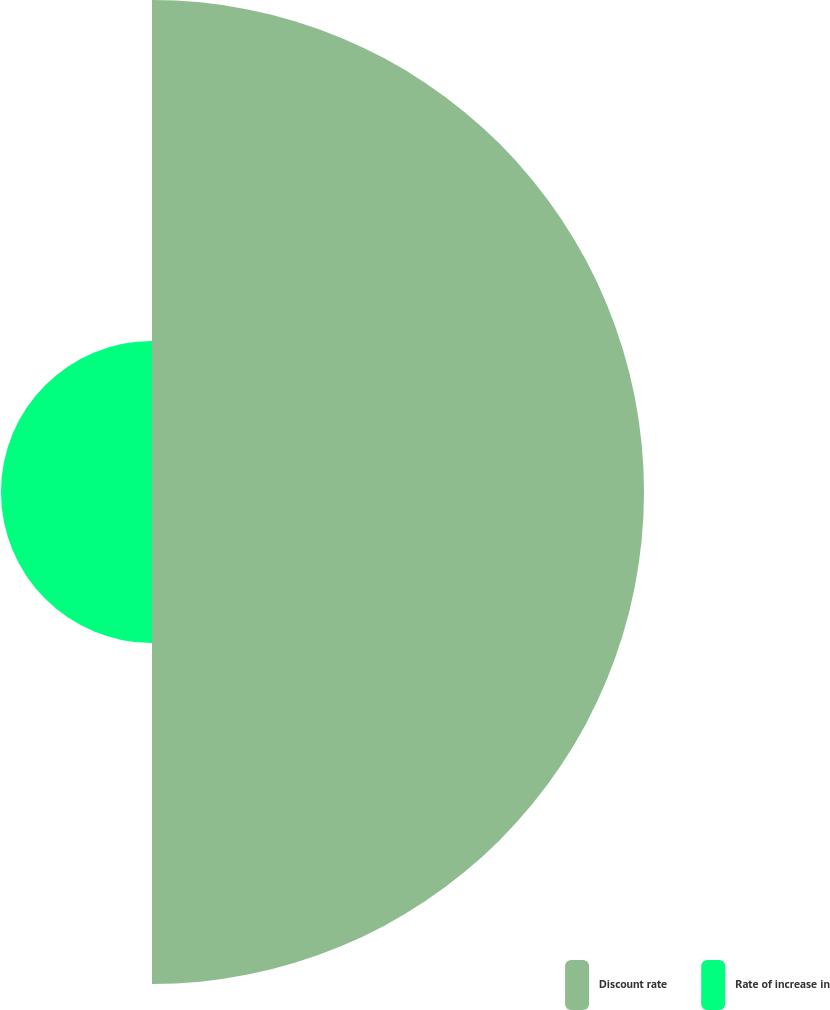Convert chart to OTSL. <chart><loc_0><loc_0><loc_500><loc_500><pie_chart><fcel>Discount rate<fcel>Rate of increase in<nl><fcel>76.51%<fcel>23.49%<nl></chart> 